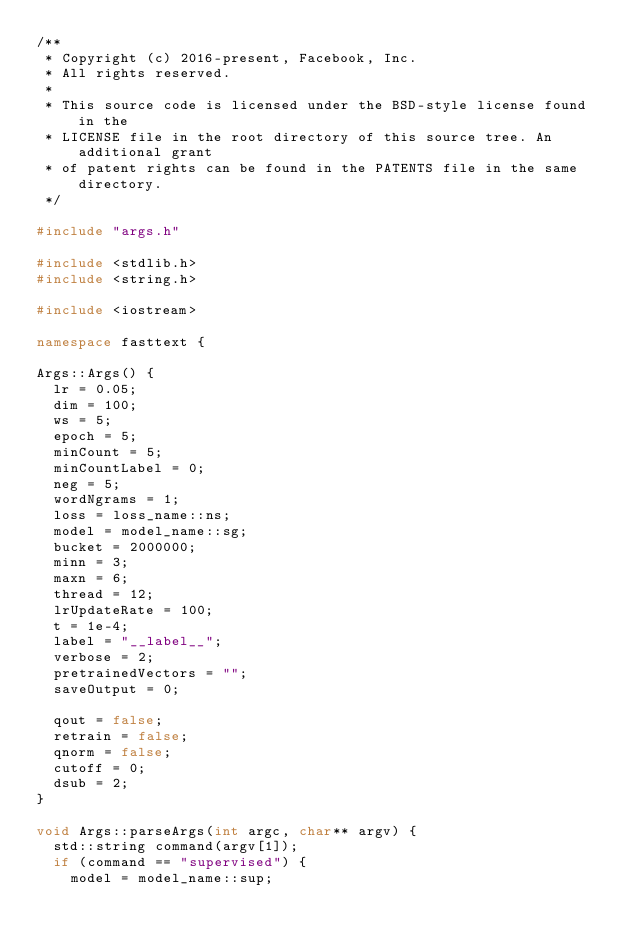<code> <loc_0><loc_0><loc_500><loc_500><_C++_>/**
 * Copyright (c) 2016-present, Facebook, Inc.
 * All rights reserved.
 *
 * This source code is licensed under the BSD-style license found in the
 * LICENSE file in the root directory of this source tree. An additional grant
 * of patent rights can be found in the PATENTS file in the same directory.
 */

#include "args.h"

#include <stdlib.h>
#include <string.h>

#include <iostream>

namespace fasttext {

Args::Args() {
  lr = 0.05;
  dim = 100;
  ws = 5;
  epoch = 5;
  minCount = 5;
  minCountLabel = 0;
  neg = 5;
  wordNgrams = 1;
  loss = loss_name::ns;
  model = model_name::sg;
  bucket = 2000000;
  minn = 3;
  maxn = 6;
  thread = 12;
  lrUpdateRate = 100;
  t = 1e-4;
  label = "__label__";
  verbose = 2;
  pretrainedVectors = "";
  saveOutput = 0;

  qout = false;
  retrain = false;
  qnorm = false;
  cutoff = 0;
  dsub = 2;
}

void Args::parseArgs(int argc, char** argv) {
  std::string command(argv[1]);
  if (command == "supervised") {
    model = model_name::sup;</code> 